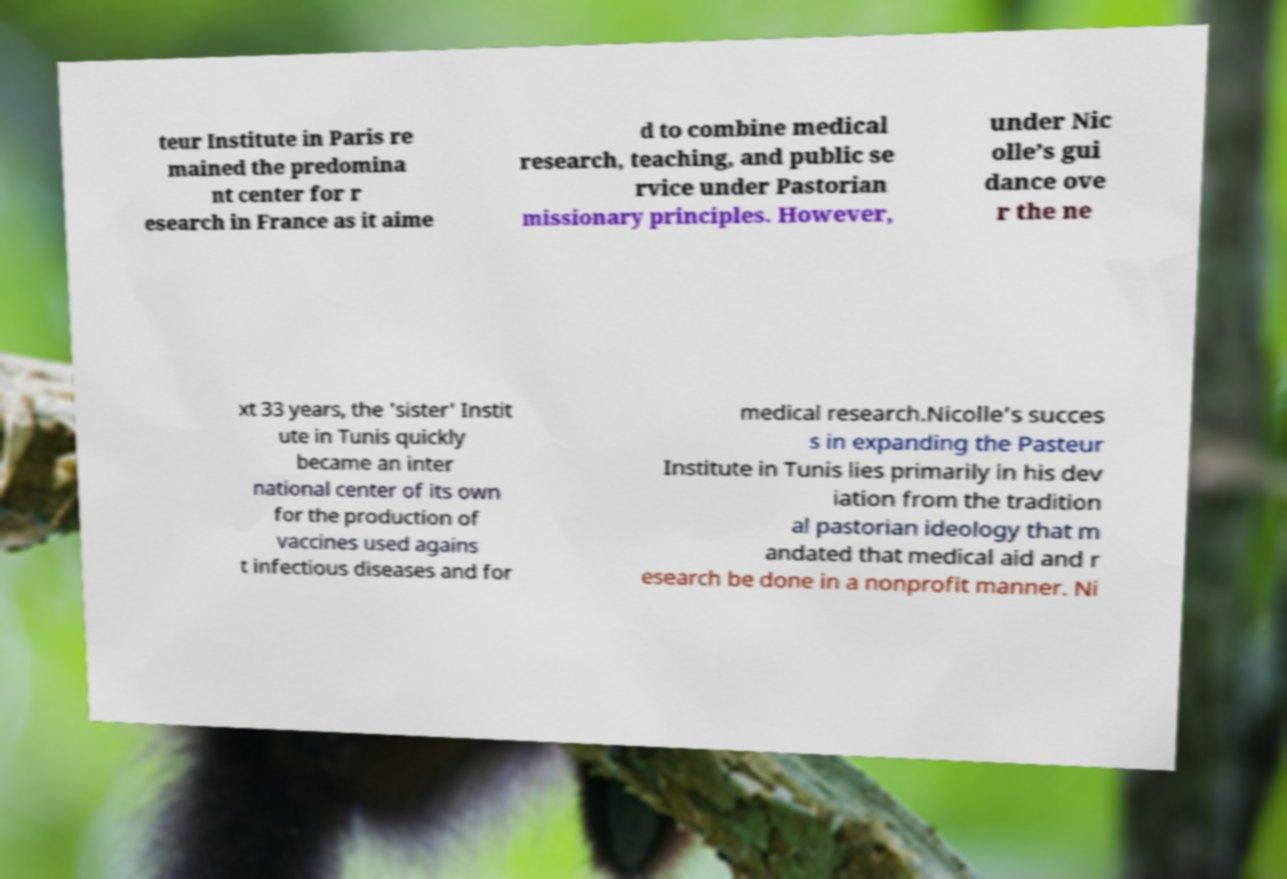Can you read and provide the text displayed in the image?This photo seems to have some interesting text. Can you extract and type it out for me? teur Institute in Paris re mained the predomina nt center for r esearch in France as it aime d to combine medical research, teaching, and public se rvice under Pastorian missionary principles. However, under Nic olle’s gui dance ove r the ne xt 33 years, the 'sister' Instit ute in Tunis quickly became an inter national center of its own for the production of vaccines used agains t infectious diseases and for medical research.Nicolle’s succes s in expanding the Pasteur Institute in Tunis lies primarily in his dev iation from the tradition al pastorian ideology that m andated that medical aid and r esearch be done in a nonprofit manner. Ni 